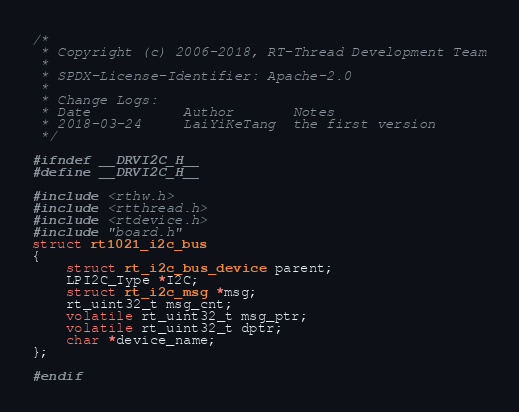Convert code to text. <code><loc_0><loc_0><loc_500><loc_500><_C_>/*
 * Copyright (c) 2006-2018, RT-Thread Development Team
 *
 * SPDX-License-Identifier: Apache-2.0
 *
 * Change Logs:
 * Date           Author       Notes
 * 2018-03-24     LaiYiKeTang  the first version
 */

#ifndef __DRVI2C_H__
#define __DRVI2C_H__

#include <rthw.h>
#include <rtthread.h>
#include <rtdevice.h>
#include "board.h"
struct rt1021_i2c_bus
{
    struct rt_i2c_bus_device parent;
    LPI2C_Type *I2C;
    struct rt_i2c_msg *msg;
    rt_uint32_t msg_cnt;
    volatile rt_uint32_t msg_ptr;
    volatile rt_uint32_t dptr;
    char *device_name;
};

#endif

</code> 